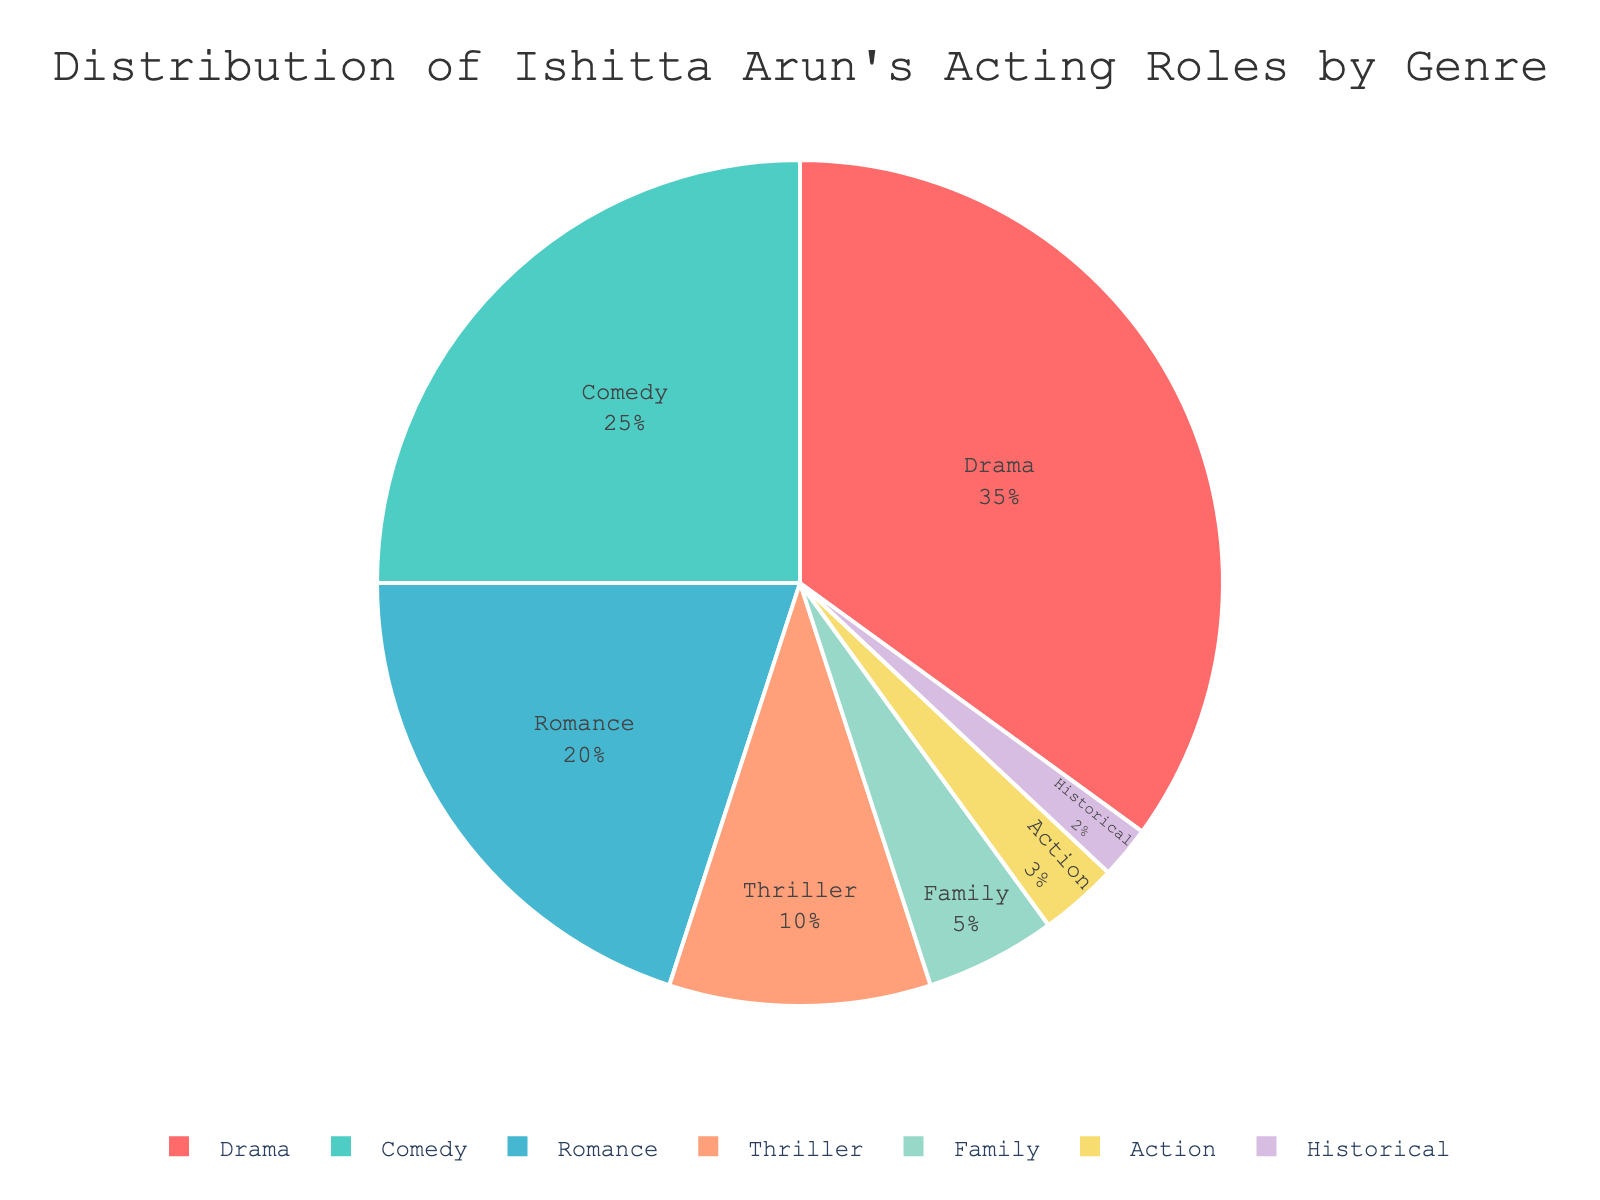What percentage of Ishitta Arun's acting roles are in genres other than Drama and Comedy? Drama and Comedy together account for 35% + 25% = 60%. Therefore, the percentage of roles in other genres is 100% - 60% = 40%.
Answer: 40% Which genre occupies the smallest portion of Ishitta Arun's acting roles and what percentage does it represent? Among the listed genres, Historical is the smallest with 2%.
Answer: Historical, 2% By how much does the percentage of Drama roles exceed the percentage of Action roles? The percentage of Drama roles is 35%, and the percentage of Action roles is 3%. The difference is 35% - 3% = 32%.
Answer: 32% Is the percentage of Romance roles greater than the combined percentage of Historical and Family roles? Romance accounts for 20%, while Historical and Family together total 2% + 5% = 7%. Since 20% > 7%, the percentage of Romance roles is indeed greater.
Answer: Yes What is the combined percentage of Drama, Romance, and Family genres? The combined percentage is 35% (Drama) + 20% (Romance) + 5% (Family) = 60%.
Answer: 60% Which genres are represented by the colors red and light green? The red segment corresponds to Drama (35%) and the light green segment corresponds to Comedy (25%).
Answer: Drama, Comedy If you remove the Family and Historical genres, what percentage of the remaining genres is Comedy? Without Family and Historical, total percentage remaining is 100% - 5% - 2% = 93%. Comedy's percentage within this remaining total is (25% / 93%) * 100% ≈ 26.88%.
Answer: Approximately 26.88% What is the visual layout and orientation of the legend in the chart? The legend is horizontally oriented and positioned below the pie chart, centered horizontally.
Answer: Horizontal, centered below How many genres have a percentage less than 10%? The genres with less than 10% are Thriller (10%), Family (5%), Action (3%), and Historical (2%). This gives a total of 4 genres.
Answer: 4 